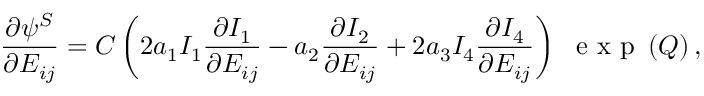<formula> <loc_0><loc_0><loc_500><loc_500>\frac { \partial \psi ^ { S } } { \partial E _ { i j } } = C \left ( 2 a _ { 1 } I _ { 1 } \frac { \partial I _ { 1 } } { \partial E _ { i j } } - a _ { 2 } \frac { \partial I _ { 2 } } { \partial E _ { i j } } + 2 a _ { 3 } I _ { 4 } \frac { \partial I _ { 4 } } { \partial E _ { i j } } \right ) \ e x p \left ( Q \right ) ,</formula> 